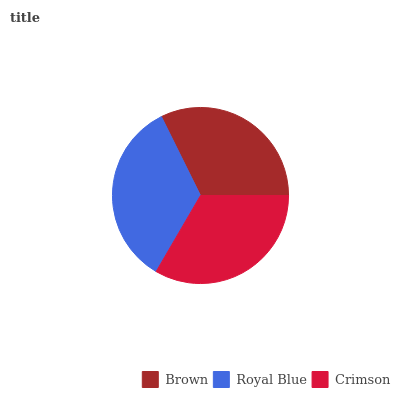Is Brown the minimum?
Answer yes or no. Yes. Is Royal Blue the maximum?
Answer yes or no. Yes. Is Crimson the minimum?
Answer yes or no. No. Is Crimson the maximum?
Answer yes or no. No. Is Royal Blue greater than Crimson?
Answer yes or no. Yes. Is Crimson less than Royal Blue?
Answer yes or no. Yes. Is Crimson greater than Royal Blue?
Answer yes or no. No. Is Royal Blue less than Crimson?
Answer yes or no. No. Is Crimson the high median?
Answer yes or no. Yes. Is Crimson the low median?
Answer yes or no. Yes. Is Royal Blue the high median?
Answer yes or no. No. Is Brown the low median?
Answer yes or no. No. 